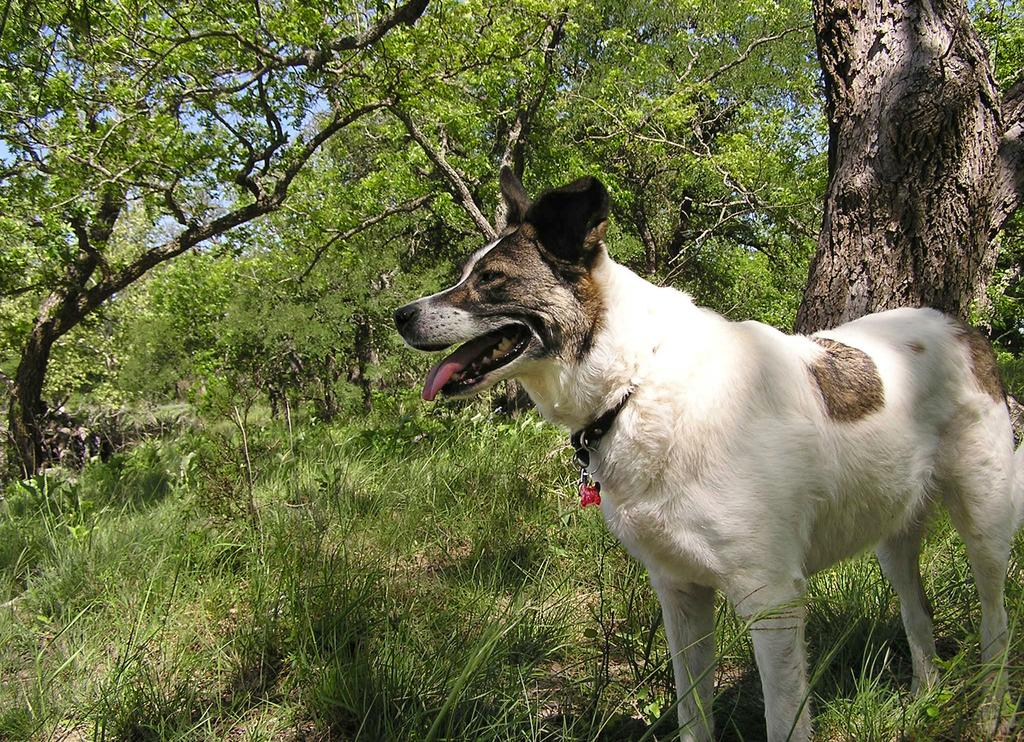What animal can be seen in the image? There is a dog in the image. In which direction is the dog facing? The dog is facing towards the left side. What type of terrain is visible at the bottom of the image? There is grass visible at the bottom of the image. What can be seen in the distance in the image? There are trees in the background of the image. What book is the dog reading in the image? There is no book present in the image, and the dog is not shown reading. 